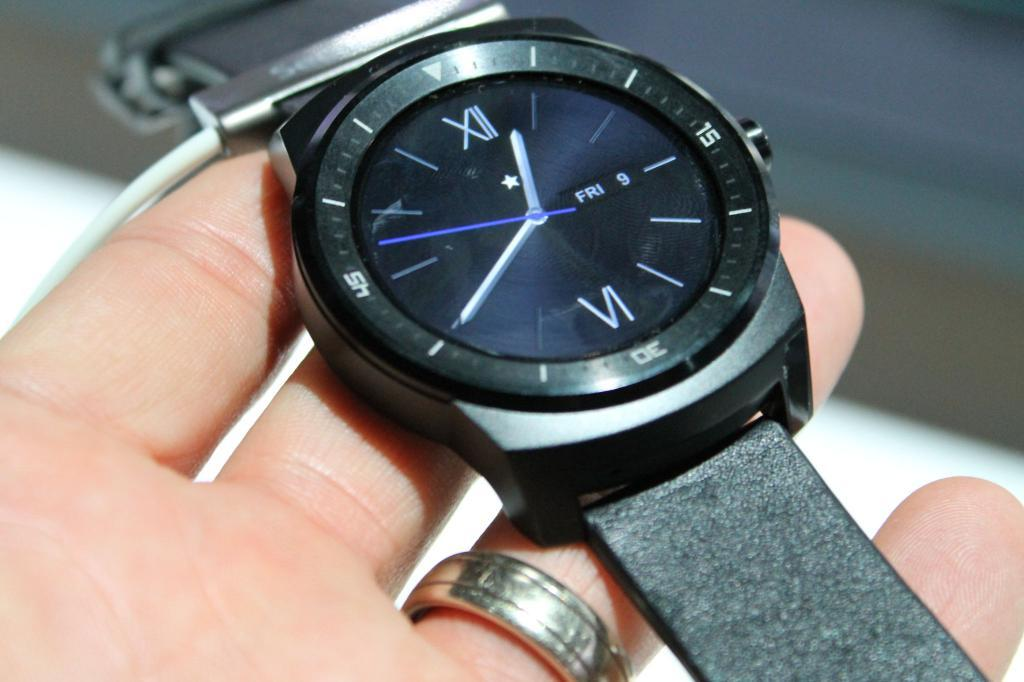<image>
Render a clear and concise summary of the photo. Person holding a black watch with roman numerals and the date Friday 9th. 